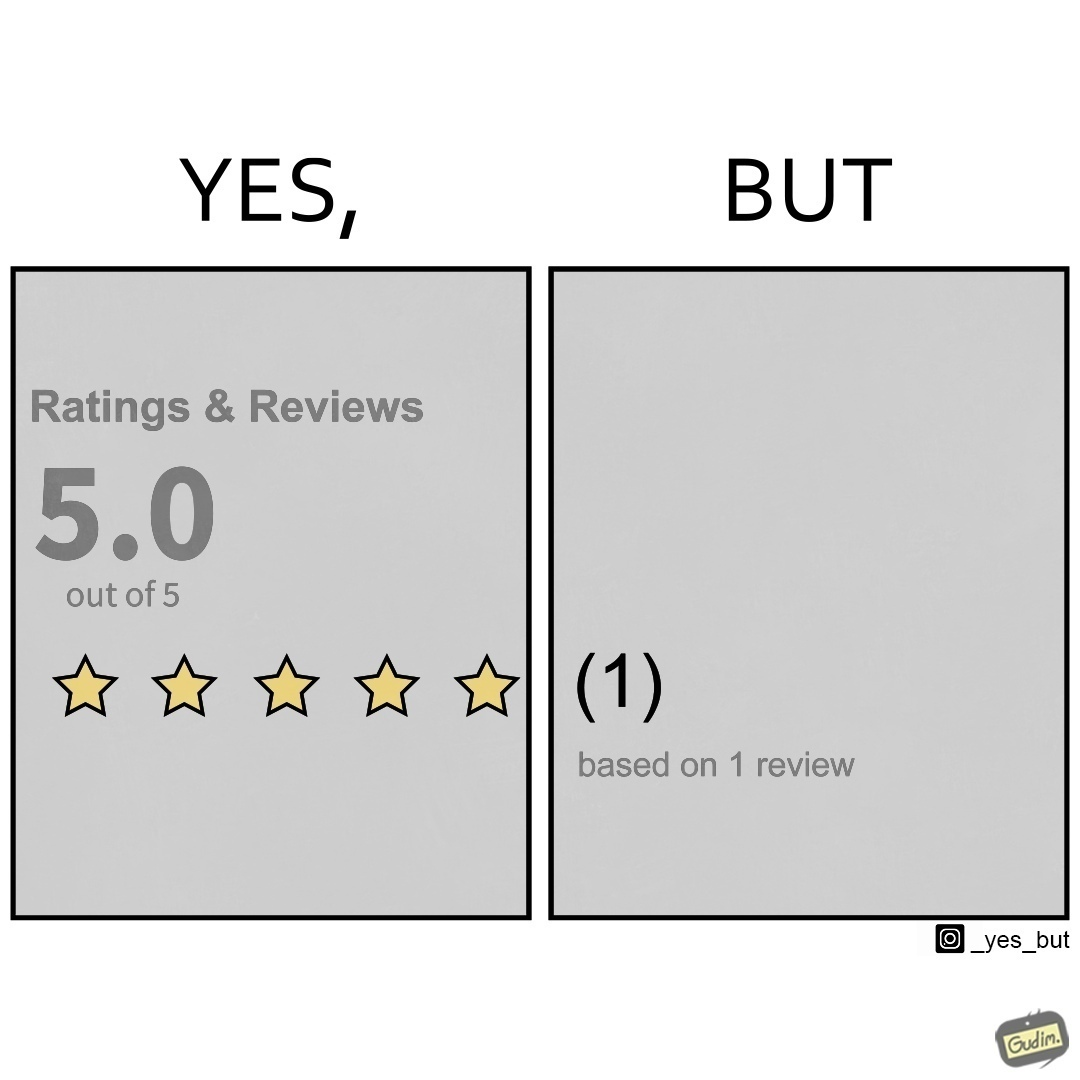What does this image depict? The image is ironical, as a product/service is rated 5 out of 5 stars, but it has only 1 review, and hence, this rating might actually be misleading. 